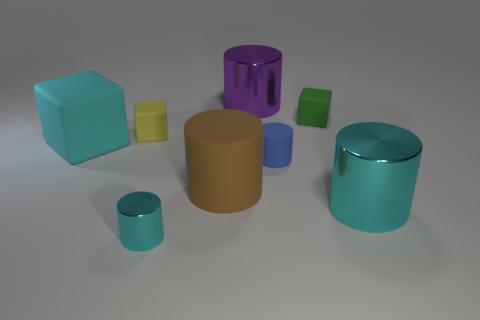What number of other things are there of the same material as the small green thing
Offer a terse response. 4. Do the blue rubber cylinder and the yellow thing have the same size?
Keep it short and to the point. Yes. What number of things are tiny matte things right of the tiny metallic cylinder or small cyan objects?
Make the answer very short. 3. There is a large cyan thing that is behind the tiny blue rubber cylinder that is behind the big cyan cylinder; what is it made of?
Provide a succinct answer. Rubber. Is there a tiny green matte object that has the same shape as the yellow matte object?
Offer a terse response. Yes. Is the size of the yellow rubber object the same as the shiny thing that is behind the green matte cube?
Your response must be concise. No. How many objects are either cyan things left of the yellow matte object or things on the right side of the blue cylinder?
Provide a short and direct response. 3. Are there more small yellow cubes that are behind the green cube than small green rubber things?
Offer a terse response. No. What number of cyan cylinders have the same size as the purple metallic cylinder?
Provide a short and direct response. 1. Is the size of the cyan metallic object behind the tiny cyan metal object the same as the cyan metal object left of the large matte cylinder?
Provide a succinct answer. No. 